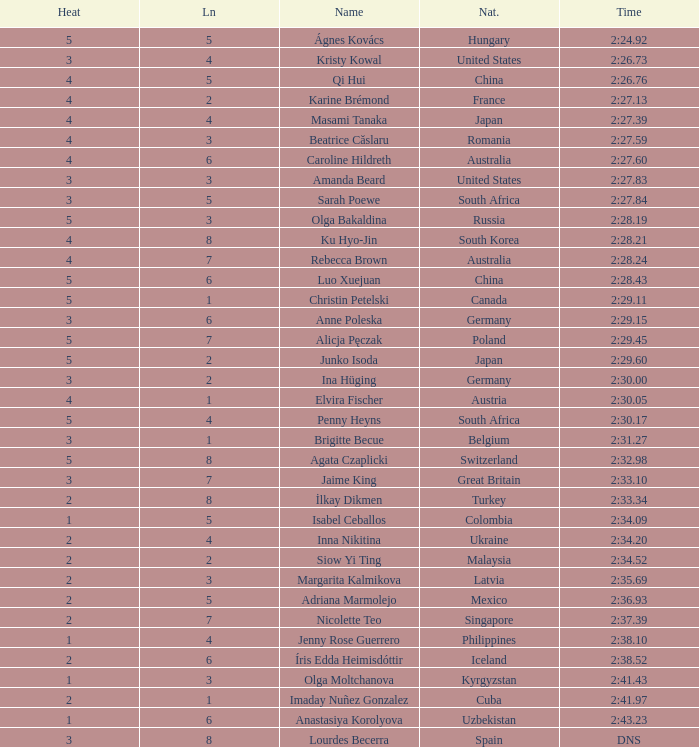What is the name that saw 4 heats and a lane higher than 7? Ku Hyo-Jin. 